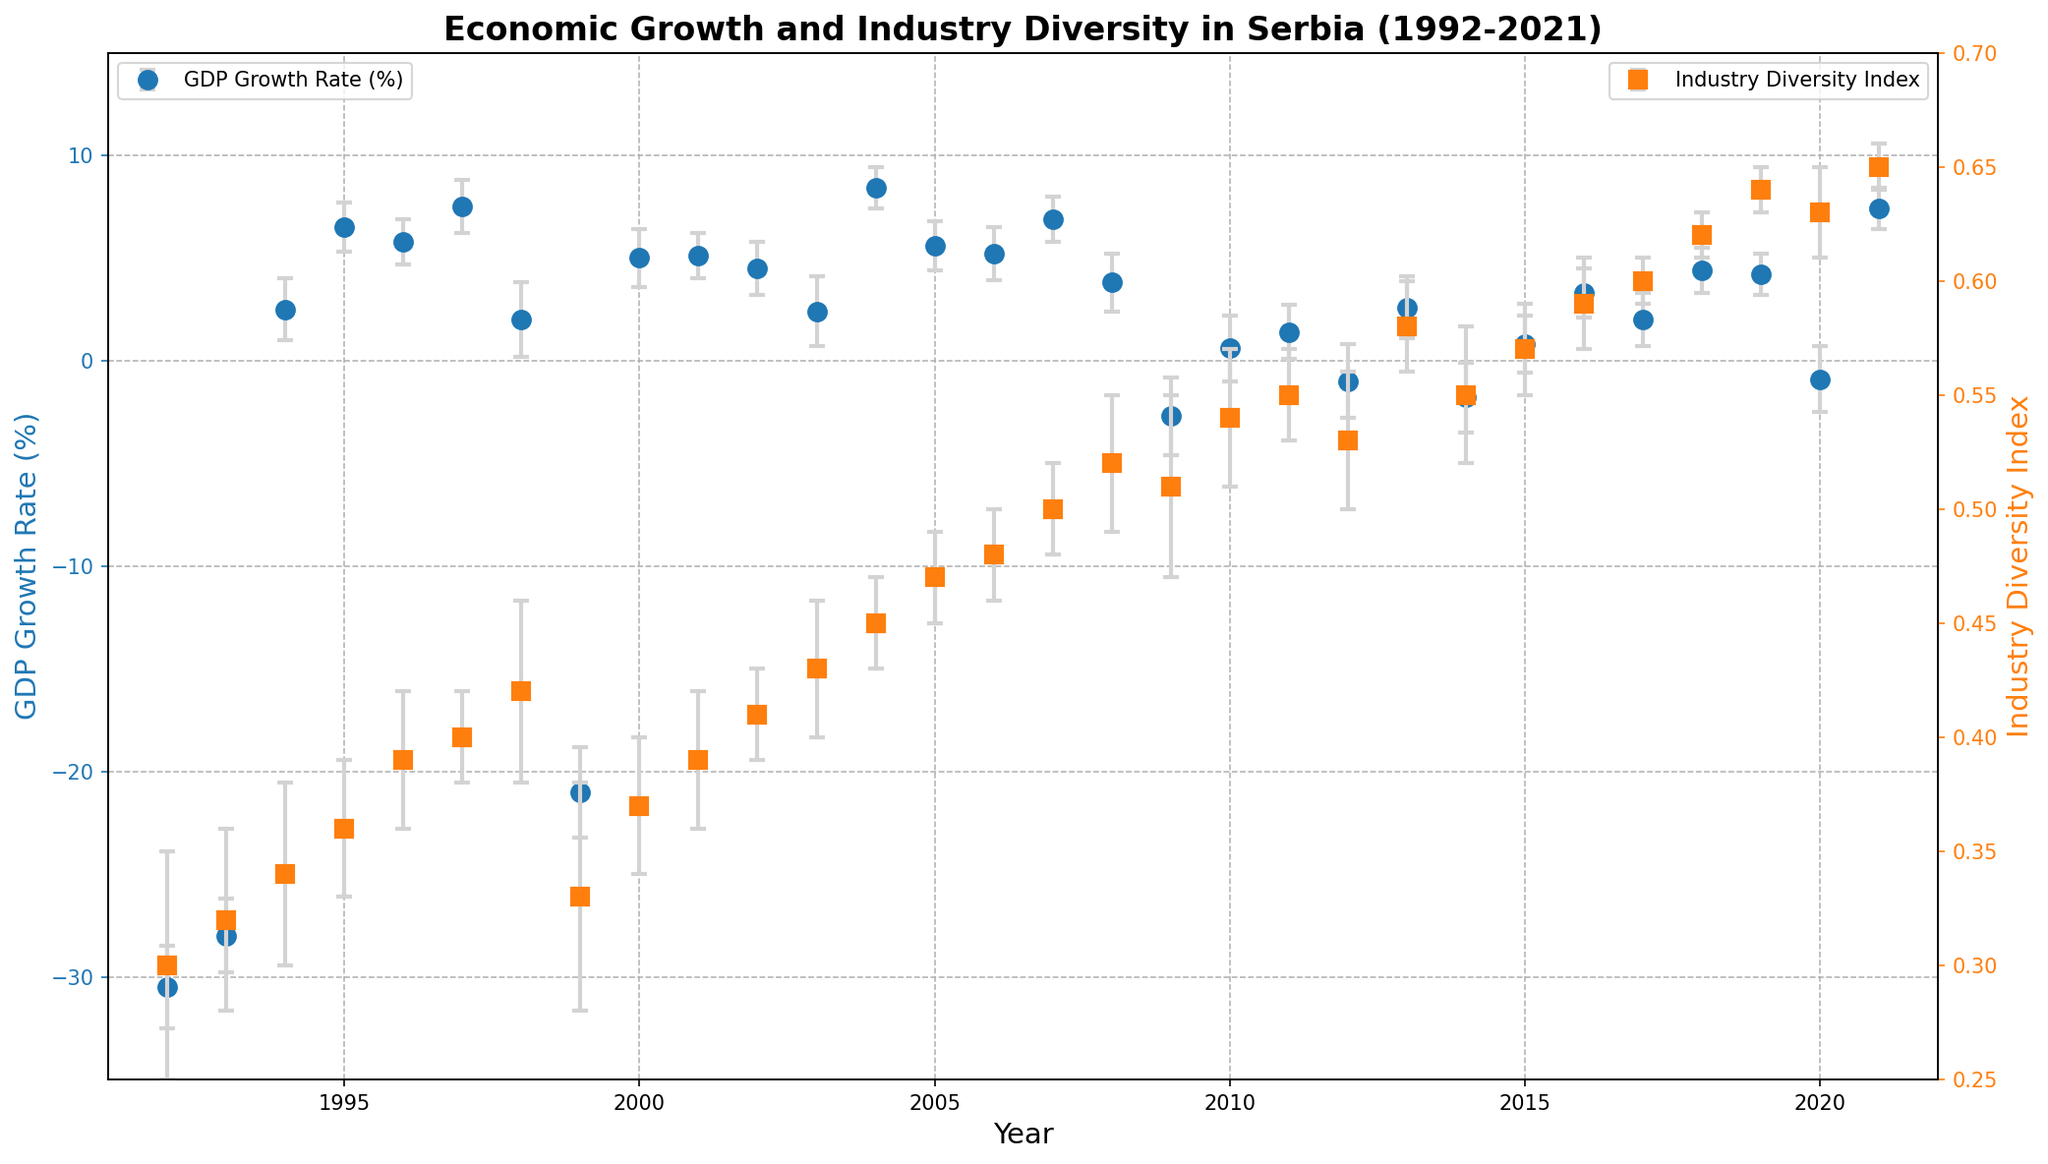What is the GDP Growth Rate in 1994? Referring to the plot, the GDP growth rate for the year 1994 is visually represented by a data point on the left y-axis. This can be observed directly on the chart.
Answer: 2.5% What trend can you observe in the Industry Diversity Index from 1992 to 2021? The Industry Diversity Index, represented on the right y-axis, shows a general upward trend, indicating increasing industry diversity over the years. This can be visually identified by the rising line and data points on the plot.
Answer: Increasing trend Which year experienced the highest GDP Growth Rate and what was its value? The highest GDP growth rate can be observed by locating the peak data point on the GDP Growth Rate axis. The chart shows the highest value around the year 2004.
Answer: 8.4% in 2004 Compare the GDP Growth Rates of 1999 and 2009, which year had a more negative growth rate? By examining the plot, the GDP Growth Rate for both years is negative. The data points for 1999 and 2009 can be compared to see that 1999 had a more negative rate.
Answer: 1999 How did the GDP Growth Rate change from 2008 to 2009? The difference in GDP Growth Rate between 2008 and 2009 can be determined by looking at the data points for both years and calculating the change. The GDP Growth Rate drops significantly in 2009.
Answer: Decreased significantly What is the relationship between GDP Growth Rate and Industry Diversity Index during the early 1990s? Observing the plot, the early 1990s show a period of negative GDP growth while the Industry Diversity Index remains relatively low and stable.
Answer: Negative GDP, low diversity In which year did the Industry Diversity Index cross the value of 0.50, and what was the GDP Growth Rate that year? Identify the year where the Industry Diversity Index first exceeds 0.50 from the right y-axis. Then, refer to the left y-axis to check the corresponding GDP Growth Rate for that year.
Answer: 2007, 6.9% What is the general visual relationship between the GDP Growth Rate and Industry Diversity Index over time? Visually, an upward trend in the Industry Diversity Index seems to correlate with periods of positive GDP Growth Rates. Both trends appear to improve together over time.
Answer: Positive correlation How does the error margin of GDP Growth Rate in 1999 compare to that in 2001? By examining the error bars (gray lines) in the chart for the years 1999 and 2001, we can see that the error margin is larger in 1999 than in 2001.
Answer: Larger in 1999 Which year between 2010 and 2020 had the highest Industry Diversity Index, and what was the value? Review the data points on the plot between the years 2010 and 2020 on the right y-axis to find the maximum Industry Diversity Index value. The highest point is around 2021.
Answer: 2021, 0.65 